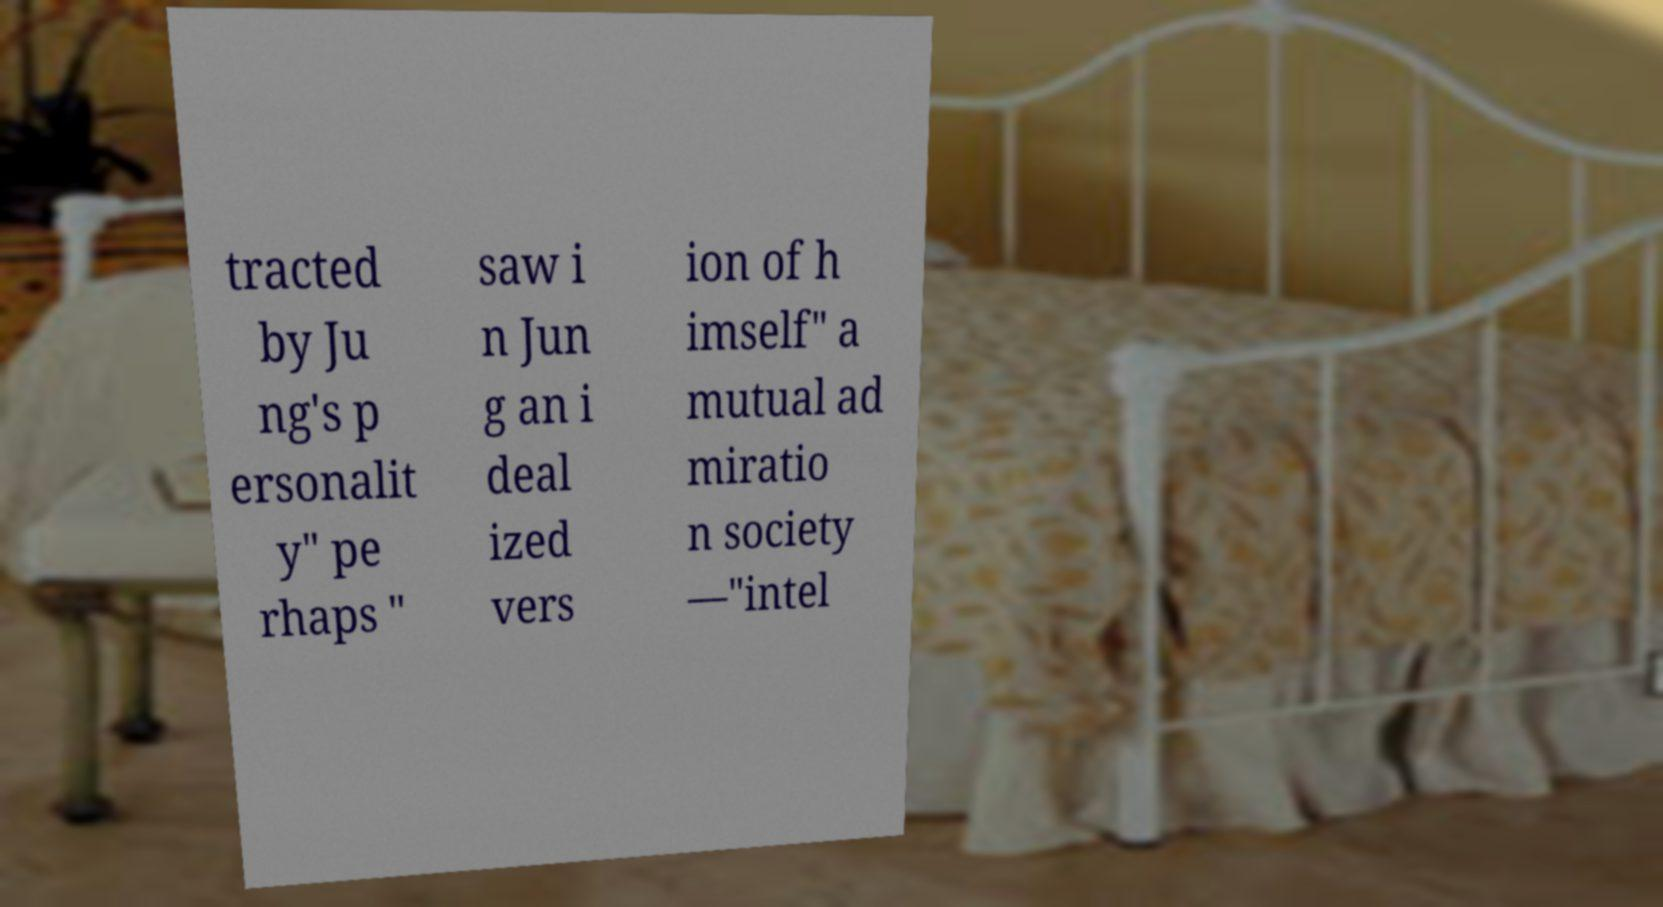Please identify and transcribe the text found in this image. tracted by Ju ng's p ersonalit y" pe rhaps " saw i n Jun g an i deal ized vers ion of h imself" a mutual ad miratio n society —"intel 